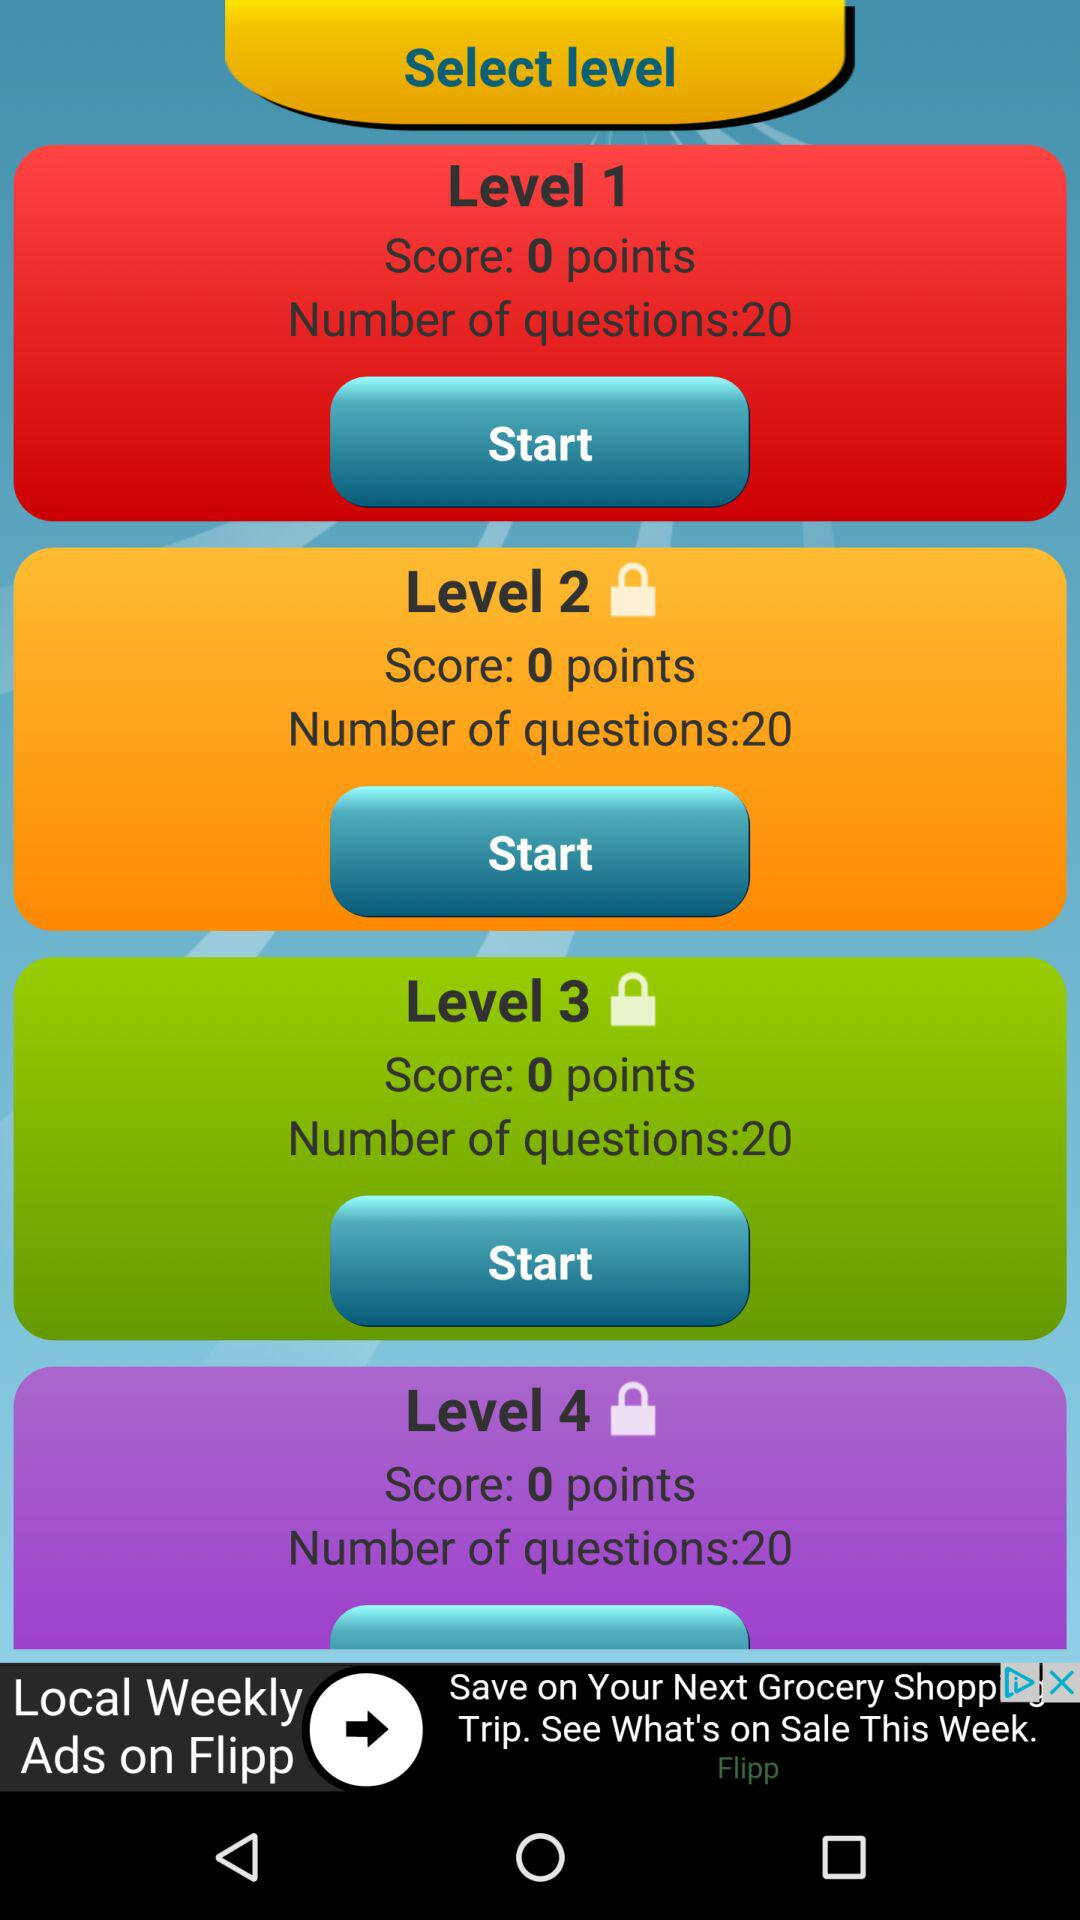What is the score of Level 1? The score is 0 points. 